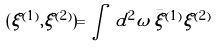<formula> <loc_0><loc_0><loc_500><loc_500>( \xi ^ { ( 1 ) } , \xi ^ { ( 2 ) } ) = \int \, d ^ { 2 } \omega \, \bar { \xi } ^ { ( 1 ) } \xi ^ { ( 2 ) }</formula> 